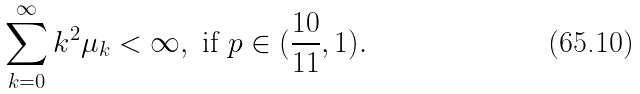<formula> <loc_0><loc_0><loc_500><loc_500>\sum _ { k = 0 } ^ { \infty } k ^ { 2 } \mu _ { k } < \infty , \ \text {if} \ p \in ( \frac { 1 0 } { 1 1 } , 1 ) .</formula> 